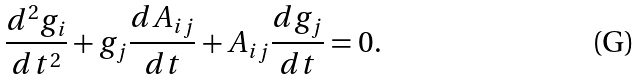Convert formula to latex. <formula><loc_0><loc_0><loc_500><loc_500>\frac { d ^ { 2 } g _ { i } } { d t ^ { 2 } } + g _ { j } \frac { d A _ { i j } } { d t } + A _ { i j } \frac { d g _ { j } } { d t } = 0 .</formula> 